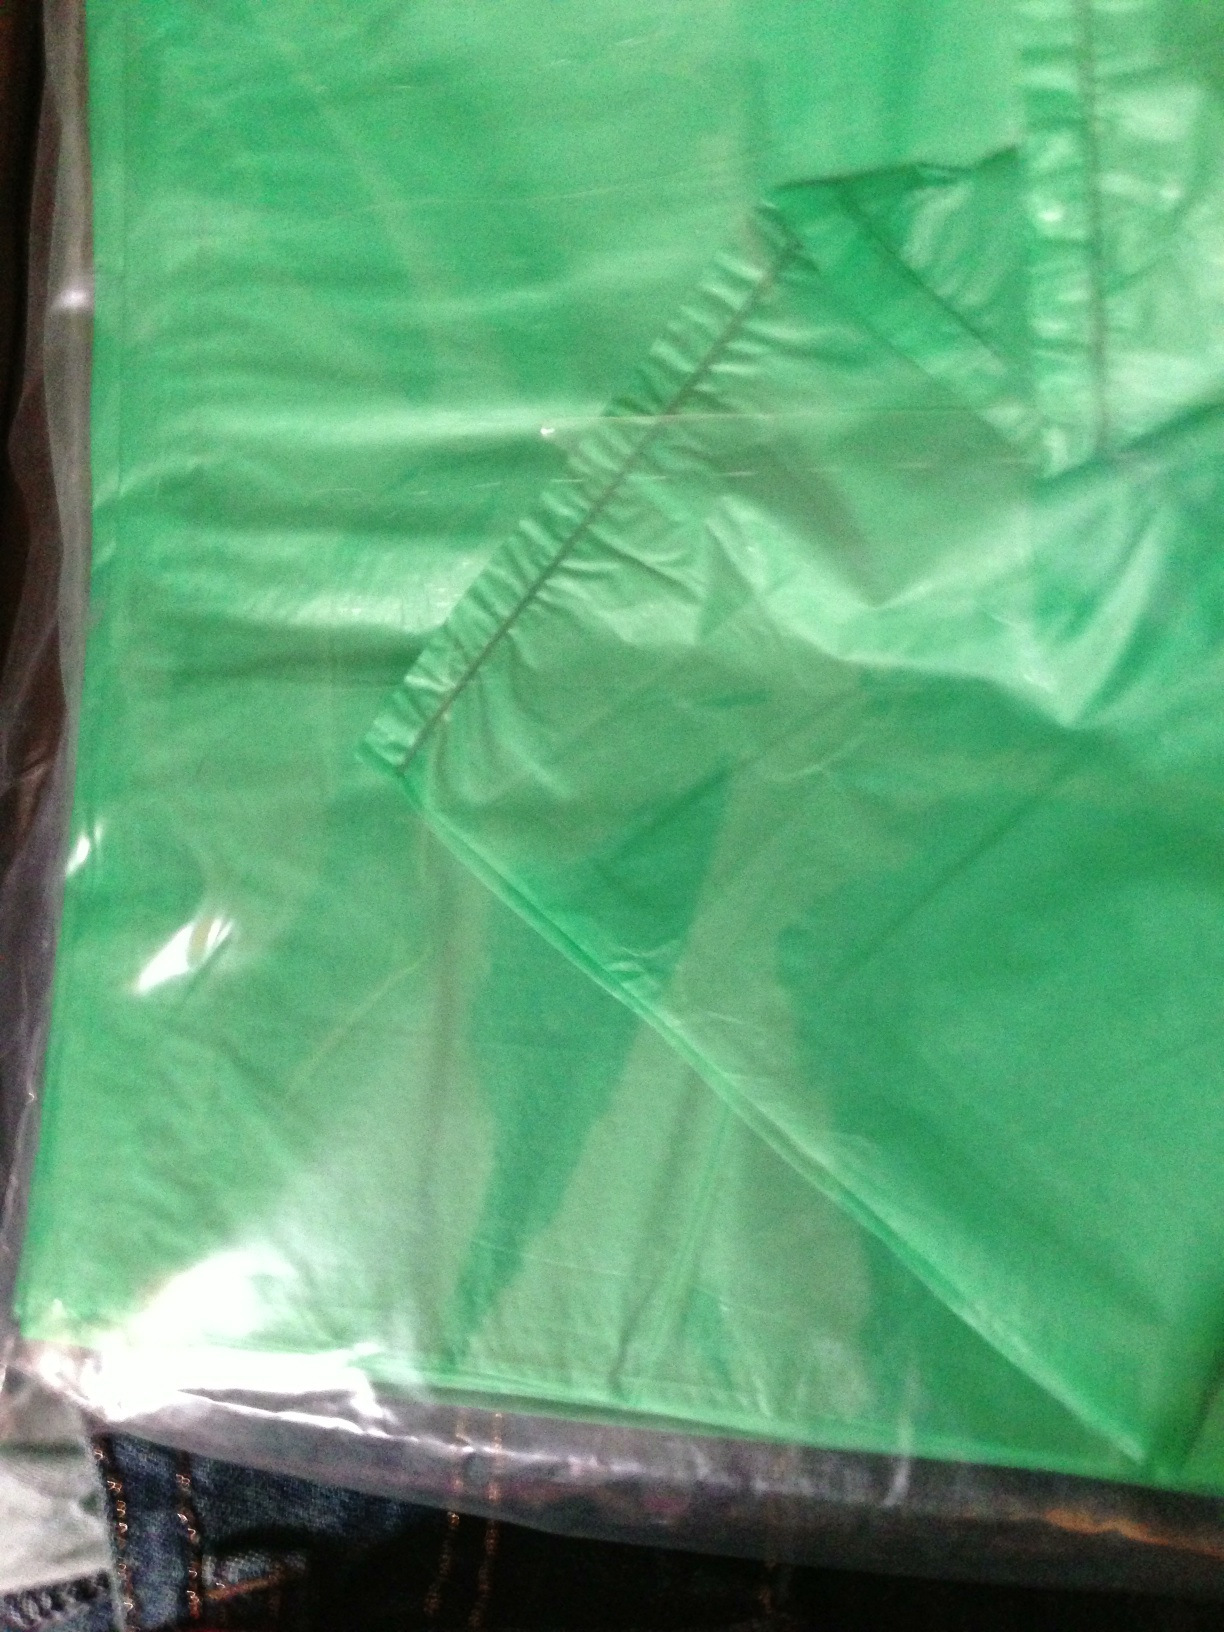Could the bag be part of a product packaging? It's possible that the bag is part of product packaging. The shiny, smooth texture and the fact that it's not fully visible could suggest that it's wrapped around an item, perhaps as part of a promotional bundle or a special edition product. 